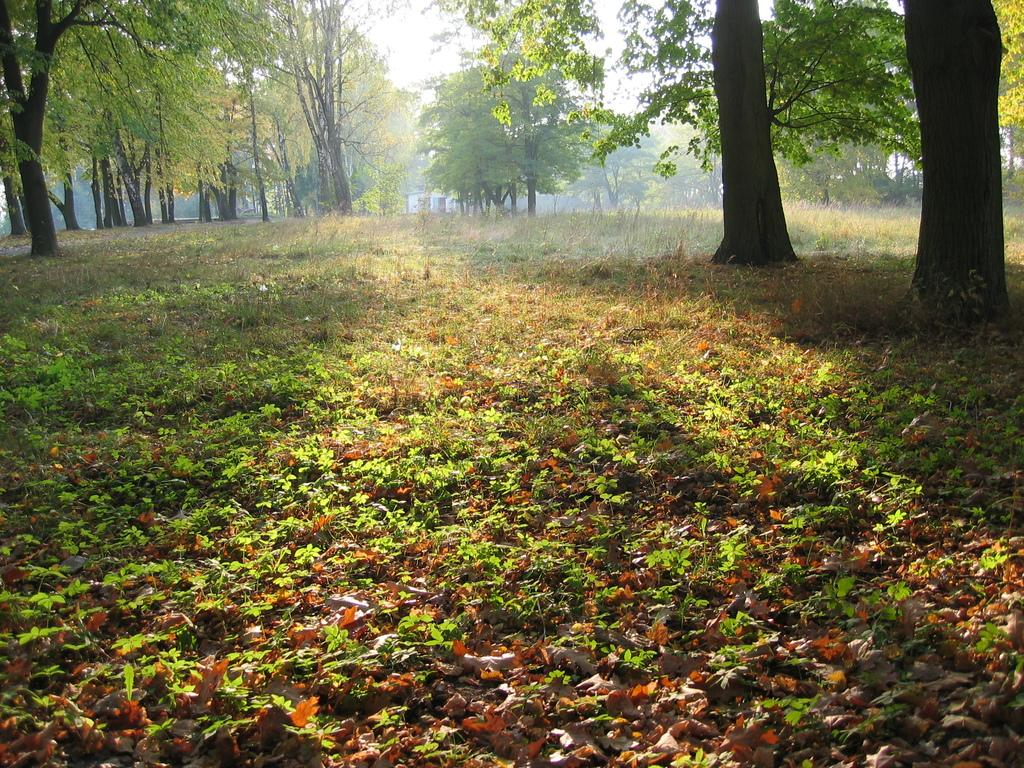What type of vegetation can be seen in the image? There are trees in the image. What structure is visible in the background of the image? There appears to be a house in the background of the image. What is visible at the top of the image? The sky is visible at the top of the image. What type of plants are at the bottom of the image? There are plants at the bottom of the image. What additional detail can be observed in the image? Dried leaves are present in the image. What type of coat is the earth wearing in the image? There is no reference to the earth or any coats in the image; it features trees, a house, plants, and dried leaves. What is the aftermath of the event depicted in the image? There is no event or aftermath depicted in the image; it is a static scene of trees, a house, plants, and dried leaves. 